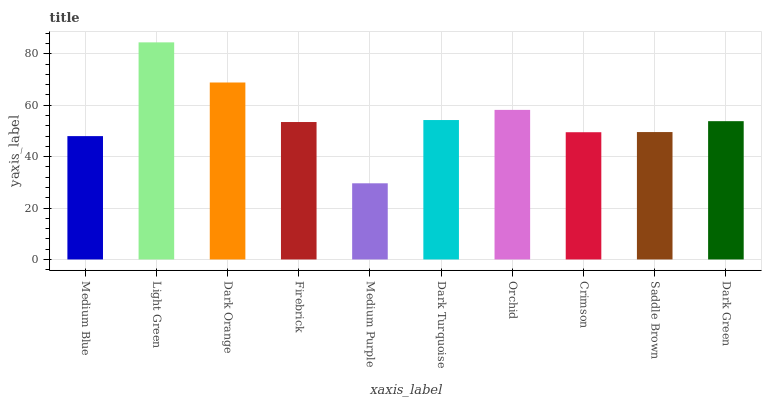Is Medium Purple the minimum?
Answer yes or no. Yes. Is Light Green the maximum?
Answer yes or no. Yes. Is Dark Orange the minimum?
Answer yes or no. No. Is Dark Orange the maximum?
Answer yes or no. No. Is Light Green greater than Dark Orange?
Answer yes or no. Yes. Is Dark Orange less than Light Green?
Answer yes or no. Yes. Is Dark Orange greater than Light Green?
Answer yes or no. No. Is Light Green less than Dark Orange?
Answer yes or no. No. Is Dark Green the high median?
Answer yes or no. Yes. Is Firebrick the low median?
Answer yes or no. Yes. Is Firebrick the high median?
Answer yes or no. No. Is Dark Turquoise the low median?
Answer yes or no. No. 